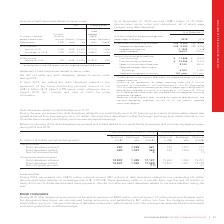According to Rogers Communications's financial document, How many debt derivatives related to senior notes during 2019 were settled? We did not settle any debt derivatives related to senior notes during 2019.. The document states: "lement of debt derivatives related to senior notes We did not settle any debt derivatives related to senior notes during 2019...." Also, When were the debt derivatives related to the repayment due? According to the financial document, August 2018. The relevant text states: "($1.8 billion) 6.8% senior notes otherwise due in August 2018. See “Sources and Uses of Cash” for more information...." Also, What was the hedge interest rate in April 30, 2019? According to the financial document, 4.173%. The relevant text states: "2019 issuances April 30, 2019 1,250 2049 4.350% 4.173% 1,676 November 12, 2019 1,000 2049 3.700% 3.996% 1,308..." Also, can you calculate: What was the increase / (decrease) in the coupon rate from November 12, 2019 to April 30, 2019? Based on the calculation: 3.996% - 4.173%, the result is -0.18 (percentage). This is based on the information: "4.173% 1,676 November 12, 2019 1,000 2049 3.700% 3.996% 1,308 2019 issuances April 30, 2019 1,250 2049 4.350% 4.173% 1,676 November 12, 2019 1,000 2049 3.700% 3.996% 1,308..." The key data points involved are: 3.996, 4.173. Also, can you calculate: What was the increase / (decrease) in the Equivalent (Cdn$) between 2018 and November 2019? Based on the calculation: 1,308 - 938, the result is 370 (in millions). This is based on the information: "issuances February 8, 2018 750 2048 4.300% 4.193% 938 1,676 November 12, 2019 1,000 2049 3.700% 3.996% 1,308..." The key data points involved are: 1,308, 938. Also, can you calculate: What was the average Principal/ Notional amount in 2019? To answer this question, I need to perform calculations using the financial data. The calculation is: (1,250 + 1,000) / 2, which equals 1125 (in millions). This is based on the information: "1,250 2049 4.350% 4.173% 1,676 November 12, 2019 1,000 2049 3.700% 3.996% 1,308 2019 issuances April 30, 2019 1,250 2049 4.350% 4.173% 1,676 November 12, 2019 1,000 2049 3.700% 3.996% 1,308..." The key data points involved are: 1,000, 1,250. 